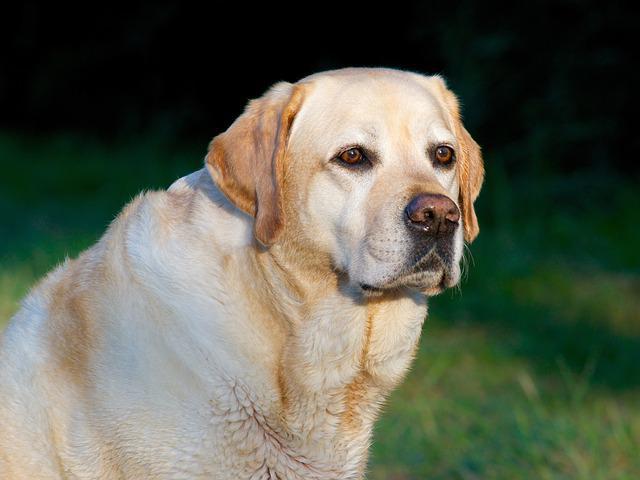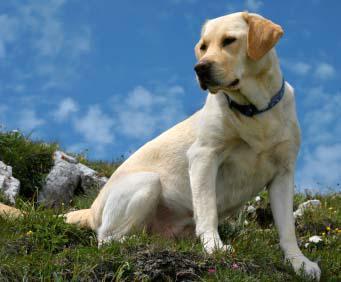The first image is the image on the left, the second image is the image on the right. Evaluate the accuracy of this statement regarding the images: "One dog has at least two paws on cement.". Is it true? Answer yes or no. No. 